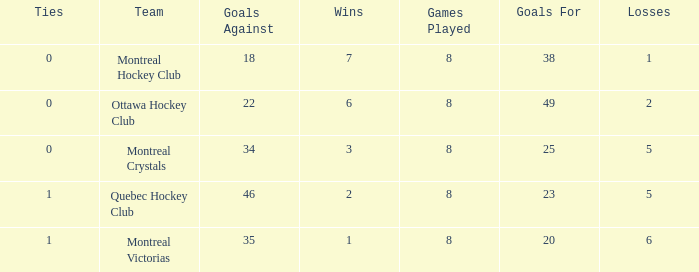What are the typical losses when there are 3 victories? 5.0. 